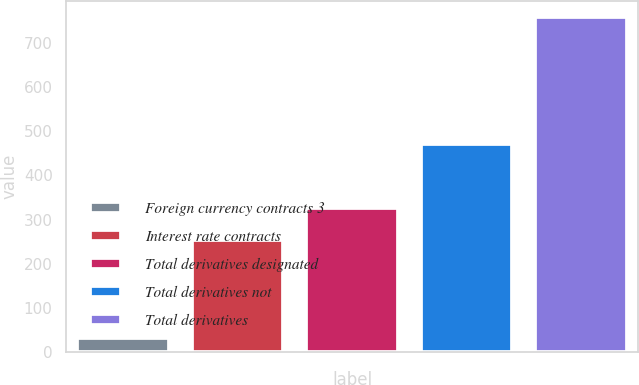<chart> <loc_0><loc_0><loc_500><loc_500><bar_chart><fcel>Foreign currency contracts 3<fcel>Interest rate contracts<fcel>Total derivatives designated<fcel>Total derivatives not<fcel>Total derivatives<nl><fcel>32<fcel>254<fcel>326.5<fcel>471<fcel>757<nl></chart> 